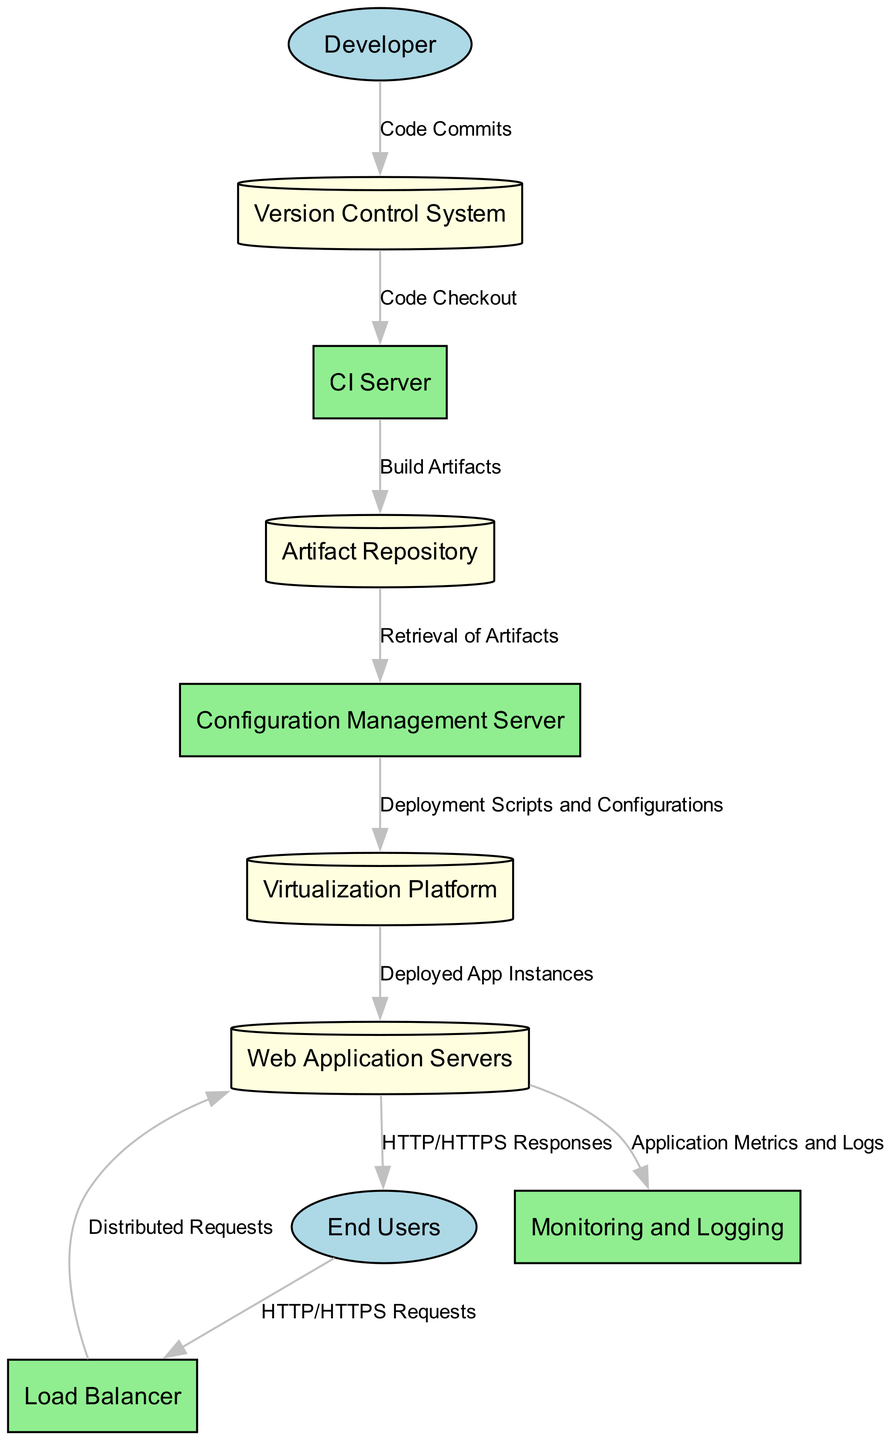What is the type of the "CI Server"? The "CI Server" is categorized as a process in the diagram. It performs specific tasks in the deployment pipeline related to continuous integration. This is indicated by its labeling as a process and the description provided in the diagram.
Answer: process How many external entities are present in the diagram? There are two external entities: "Developer" and "End Users". Each is represented in the diagram and serves a distinct role in the deployment pipeline's flow.
Answer: 2 What data flows from the "Version Control System" to the "CI Server"? The data flowing from the "Version Control System" to the "CI Server" is labeled as "Code Checkout". This is depicted in the diagram as a directed connection between these two components.
Answer: Code Checkout Which entity is responsible for distributing incoming web traffic? The "Load Balancer" is responsible for distributing incoming web traffic. This is indicated in the diagram as it connects the "End Users" to the "Web Application Servers".
Answer: Load Balancer What is retrieved by the "Configuration Management Server" from the "Artifact Repository"? The "Configuration Management Server" retrieves "Build Artifacts" from the "Artifact Repository". This flow is shown in the diagram and highlights the relationship in the deployment process.
Answer: Retrieval of Artifacts What does the "Web Application Servers" send to "End Users"? The "Web Application Servers" send "HTTP/HTTPS Responses" to "End Users". This interaction is described in the diagram as a flow from the web application servers back to users.
Answer: HTTP/HTTPS Responses Where do "Deployed App Instances" go after the "Virtualization Platform"? After the "Virtualization Platform", the "Deployed App Instances" are directed towards the "Web Application Servers". This shows the process of deploying the application to the appropriate servers.
Answer: Web Application Servers What is monitored by the "Monitoring and Logging" process? The "Monitoring and Logging" process tracks "Application Metrics and Logs" generated by the "Web Application Servers". This is depicted as a flow where data from the application servers is sent to the monitoring process.
Answer: Application Metrics and Logs How many data flows originate from the "Web Application Servers"? There are two data flows originating from the "Web Application Servers": one to the "End Users" for responses and another to "Monitoring and Logging" for metrics and logs. This count is derived from the diagram analysis.
Answer: 2 